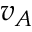Convert formula to latex. <formula><loc_0><loc_0><loc_500><loc_500>v _ { A }</formula> 